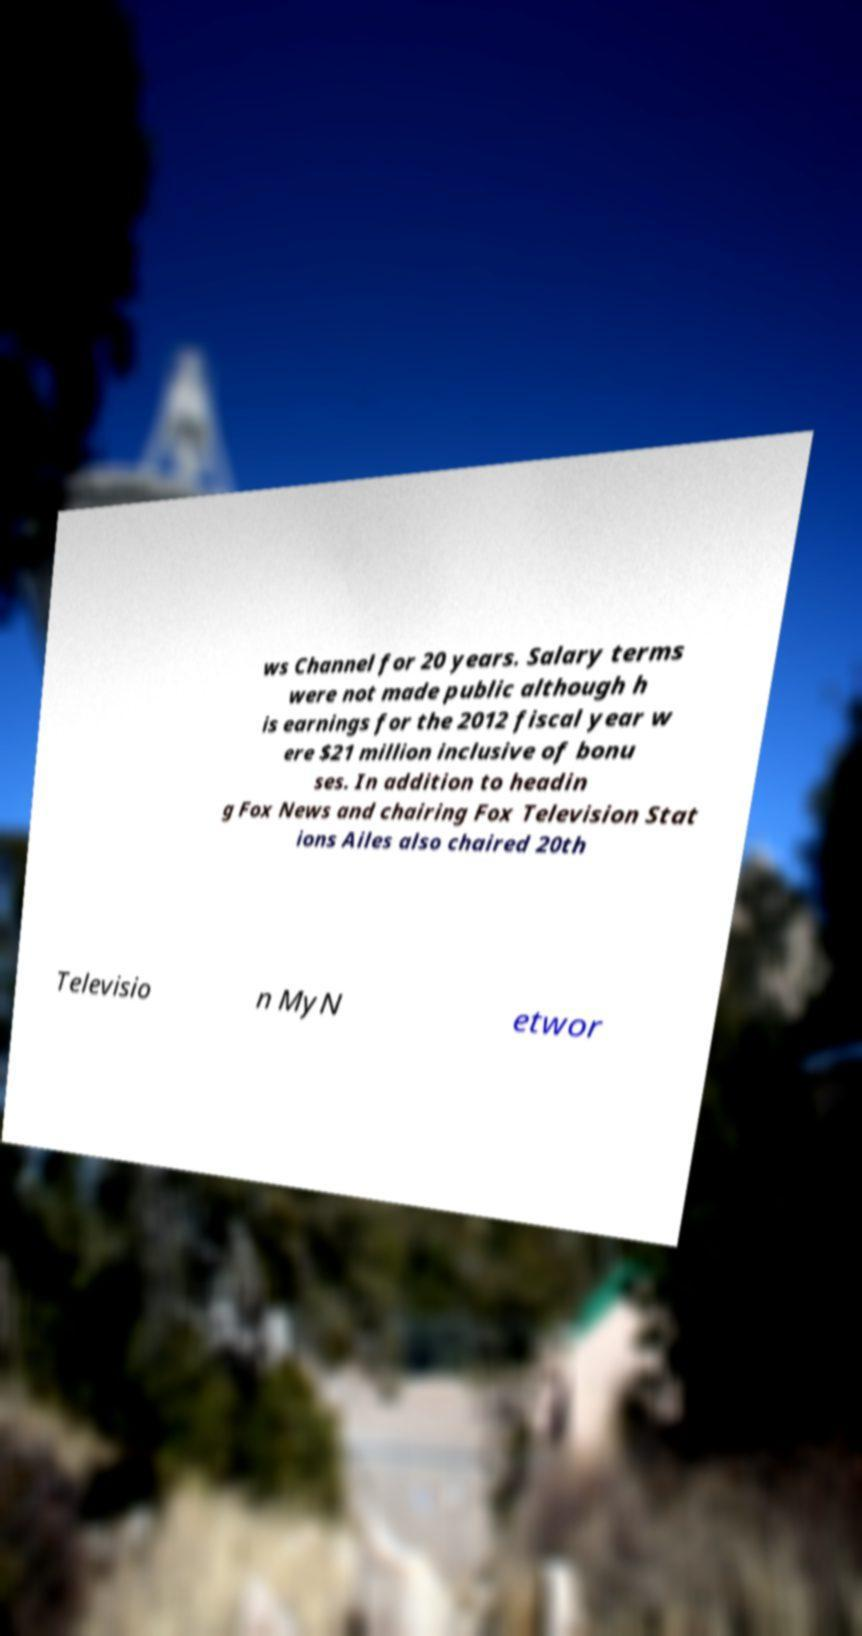Could you assist in decoding the text presented in this image and type it out clearly? ws Channel for 20 years. Salary terms were not made public although h is earnings for the 2012 fiscal year w ere $21 million inclusive of bonu ses. In addition to headin g Fox News and chairing Fox Television Stat ions Ailes also chaired 20th Televisio n MyN etwor 